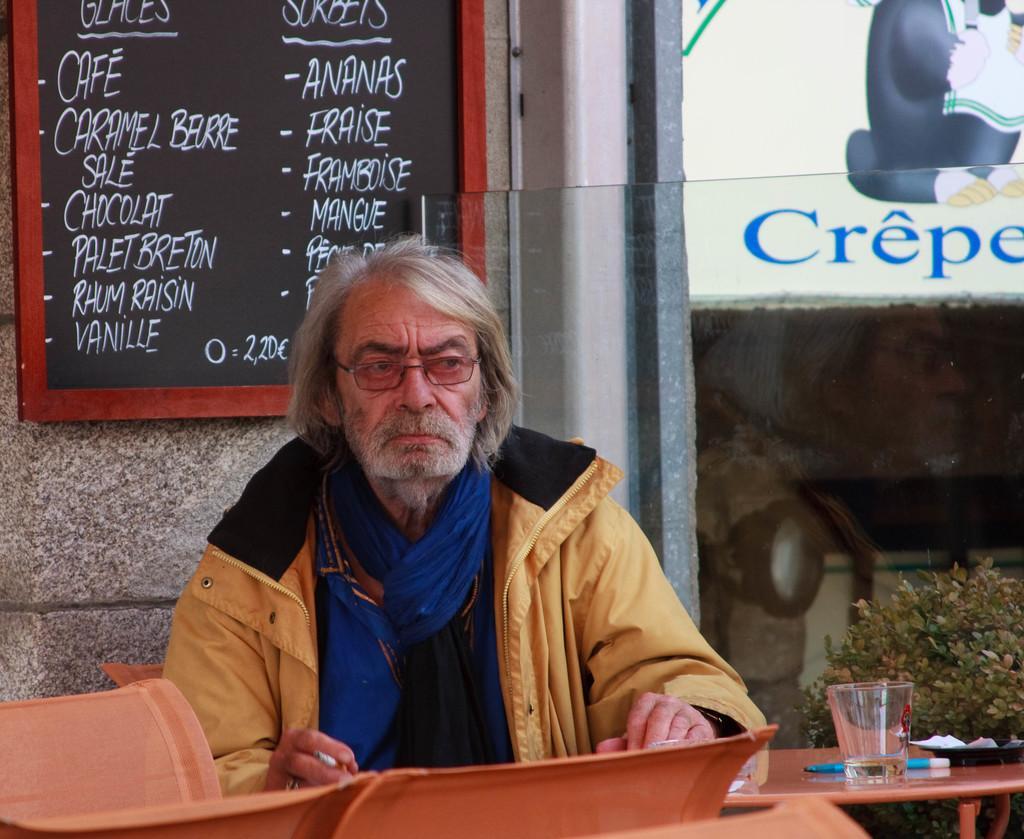Describe this image in one or two sentences. In this image there is a man he is wearing brown color jacket and sitting in a chair, in front of there is a table, on that table there is a pen, glass, in the background there is wall to that wall there is board. 